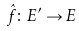<formula> <loc_0><loc_0><loc_500><loc_500>\hat { f } \colon E ^ { \prime } \rightarrow E</formula> 